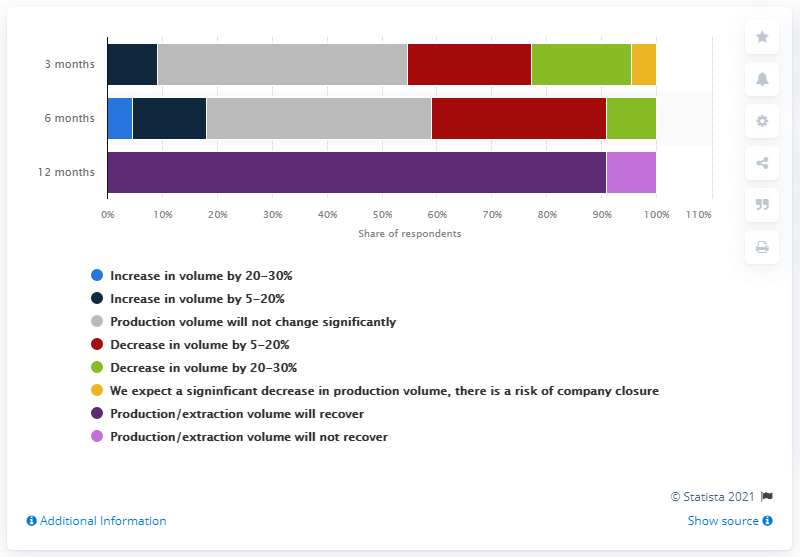Identify some key points in this picture. According to a recent survey, over 90% of Russian mining and metals companies expect their production to recover from the impact of the coronavirus. According to a recent survey, 91% of Russian mining and metals companies expect production to take 12 months or more to fully recover from the impact of the COVID-19 pandemic. 